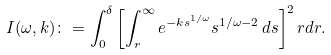Convert formula to latex. <formula><loc_0><loc_0><loc_500><loc_500>I ( \omega , k ) \colon = \int _ { 0 } ^ { \delta } \left [ \int _ { r } ^ { \infty } { e ^ { - k s ^ { 1 / \omega } } s ^ { 1 / \omega - 2 } } \, d s \right ] ^ { 2 } r d r .</formula> 